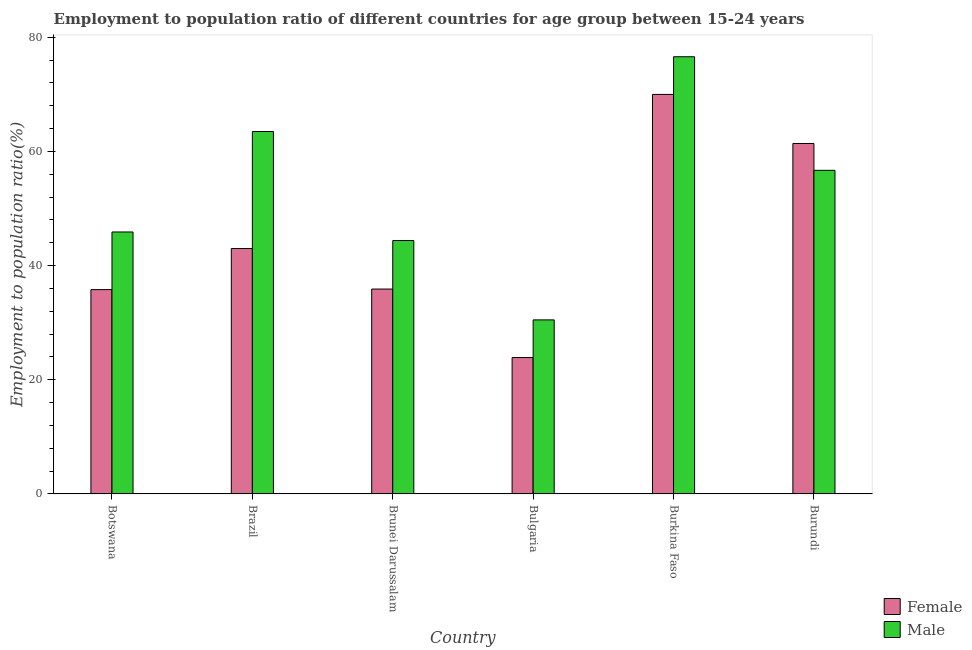How many different coloured bars are there?
Make the answer very short. 2. Are the number of bars per tick equal to the number of legend labels?
Your answer should be very brief. Yes. What is the label of the 6th group of bars from the left?
Ensure brevity in your answer.  Burundi. In how many cases, is the number of bars for a given country not equal to the number of legend labels?
Your answer should be very brief. 0. What is the employment to population ratio(female) in Brazil?
Keep it short and to the point. 43. Across all countries, what is the maximum employment to population ratio(female)?
Offer a terse response. 70. Across all countries, what is the minimum employment to population ratio(male)?
Provide a short and direct response. 30.5. In which country was the employment to population ratio(male) maximum?
Your answer should be very brief. Burkina Faso. What is the total employment to population ratio(female) in the graph?
Offer a terse response. 270. What is the difference between the employment to population ratio(female) in Botswana and that in Brunei Darussalam?
Give a very brief answer. -0.1. What is the difference between the employment to population ratio(male) in Brunei Darussalam and the employment to population ratio(female) in Botswana?
Your answer should be compact. 8.6. What is the average employment to population ratio(female) per country?
Your response must be concise. 45. What is the difference between the employment to population ratio(male) and employment to population ratio(female) in Botswana?
Keep it short and to the point. 10.1. What is the ratio of the employment to population ratio(female) in Brazil to that in Burkina Faso?
Offer a very short reply. 0.61. What is the difference between the highest and the second highest employment to population ratio(female)?
Keep it short and to the point. 8.6. What is the difference between the highest and the lowest employment to population ratio(female)?
Provide a succinct answer. 46.1. How many countries are there in the graph?
Give a very brief answer. 6. What is the difference between two consecutive major ticks on the Y-axis?
Provide a succinct answer. 20. What is the title of the graph?
Make the answer very short. Employment to population ratio of different countries for age group between 15-24 years. What is the label or title of the X-axis?
Your answer should be very brief. Country. What is the Employment to population ratio(%) of Female in Botswana?
Your answer should be very brief. 35.8. What is the Employment to population ratio(%) of Male in Botswana?
Ensure brevity in your answer.  45.9. What is the Employment to population ratio(%) in Male in Brazil?
Offer a terse response. 63.5. What is the Employment to population ratio(%) of Female in Brunei Darussalam?
Offer a very short reply. 35.9. What is the Employment to population ratio(%) in Male in Brunei Darussalam?
Make the answer very short. 44.4. What is the Employment to population ratio(%) in Female in Bulgaria?
Ensure brevity in your answer.  23.9. What is the Employment to population ratio(%) in Male in Bulgaria?
Offer a very short reply. 30.5. What is the Employment to population ratio(%) of Female in Burkina Faso?
Your answer should be compact. 70. What is the Employment to population ratio(%) of Male in Burkina Faso?
Keep it short and to the point. 76.6. What is the Employment to population ratio(%) in Female in Burundi?
Your response must be concise. 61.4. What is the Employment to population ratio(%) in Male in Burundi?
Make the answer very short. 56.7. Across all countries, what is the maximum Employment to population ratio(%) of Male?
Ensure brevity in your answer.  76.6. Across all countries, what is the minimum Employment to population ratio(%) in Female?
Provide a short and direct response. 23.9. Across all countries, what is the minimum Employment to population ratio(%) in Male?
Offer a very short reply. 30.5. What is the total Employment to population ratio(%) of Female in the graph?
Provide a short and direct response. 270. What is the total Employment to population ratio(%) in Male in the graph?
Give a very brief answer. 317.6. What is the difference between the Employment to population ratio(%) in Male in Botswana and that in Brazil?
Your response must be concise. -17.6. What is the difference between the Employment to population ratio(%) of Male in Botswana and that in Brunei Darussalam?
Your answer should be compact. 1.5. What is the difference between the Employment to population ratio(%) of Female in Botswana and that in Bulgaria?
Provide a short and direct response. 11.9. What is the difference between the Employment to population ratio(%) in Male in Botswana and that in Bulgaria?
Your response must be concise. 15.4. What is the difference between the Employment to population ratio(%) of Female in Botswana and that in Burkina Faso?
Provide a succinct answer. -34.2. What is the difference between the Employment to population ratio(%) in Male in Botswana and that in Burkina Faso?
Provide a short and direct response. -30.7. What is the difference between the Employment to population ratio(%) of Female in Botswana and that in Burundi?
Offer a terse response. -25.6. What is the difference between the Employment to population ratio(%) in Female in Brazil and that in Brunei Darussalam?
Give a very brief answer. 7.1. What is the difference between the Employment to population ratio(%) in Male in Brazil and that in Brunei Darussalam?
Offer a terse response. 19.1. What is the difference between the Employment to population ratio(%) of Male in Brazil and that in Bulgaria?
Offer a terse response. 33. What is the difference between the Employment to population ratio(%) in Female in Brazil and that in Burkina Faso?
Provide a succinct answer. -27. What is the difference between the Employment to population ratio(%) in Female in Brazil and that in Burundi?
Ensure brevity in your answer.  -18.4. What is the difference between the Employment to population ratio(%) in Male in Brunei Darussalam and that in Bulgaria?
Your response must be concise. 13.9. What is the difference between the Employment to population ratio(%) of Female in Brunei Darussalam and that in Burkina Faso?
Your answer should be compact. -34.1. What is the difference between the Employment to population ratio(%) of Male in Brunei Darussalam and that in Burkina Faso?
Your answer should be compact. -32.2. What is the difference between the Employment to population ratio(%) in Female in Brunei Darussalam and that in Burundi?
Offer a terse response. -25.5. What is the difference between the Employment to population ratio(%) of Female in Bulgaria and that in Burkina Faso?
Your response must be concise. -46.1. What is the difference between the Employment to population ratio(%) in Male in Bulgaria and that in Burkina Faso?
Give a very brief answer. -46.1. What is the difference between the Employment to population ratio(%) in Female in Bulgaria and that in Burundi?
Offer a very short reply. -37.5. What is the difference between the Employment to population ratio(%) of Male in Bulgaria and that in Burundi?
Ensure brevity in your answer.  -26.2. What is the difference between the Employment to population ratio(%) in Female in Botswana and the Employment to population ratio(%) in Male in Brazil?
Provide a short and direct response. -27.7. What is the difference between the Employment to population ratio(%) in Female in Botswana and the Employment to population ratio(%) in Male in Brunei Darussalam?
Your response must be concise. -8.6. What is the difference between the Employment to population ratio(%) in Female in Botswana and the Employment to population ratio(%) in Male in Bulgaria?
Keep it short and to the point. 5.3. What is the difference between the Employment to population ratio(%) of Female in Botswana and the Employment to population ratio(%) of Male in Burkina Faso?
Offer a very short reply. -40.8. What is the difference between the Employment to population ratio(%) of Female in Botswana and the Employment to population ratio(%) of Male in Burundi?
Offer a very short reply. -20.9. What is the difference between the Employment to population ratio(%) of Female in Brazil and the Employment to population ratio(%) of Male in Bulgaria?
Offer a very short reply. 12.5. What is the difference between the Employment to population ratio(%) in Female in Brazil and the Employment to population ratio(%) in Male in Burkina Faso?
Provide a succinct answer. -33.6. What is the difference between the Employment to population ratio(%) in Female in Brazil and the Employment to population ratio(%) in Male in Burundi?
Your answer should be very brief. -13.7. What is the difference between the Employment to population ratio(%) of Female in Brunei Darussalam and the Employment to population ratio(%) of Male in Bulgaria?
Offer a terse response. 5.4. What is the difference between the Employment to population ratio(%) of Female in Brunei Darussalam and the Employment to population ratio(%) of Male in Burkina Faso?
Provide a short and direct response. -40.7. What is the difference between the Employment to population ratio(%) in Female in Brunei Darussalam and the Employment to population ratio(%) in Male in Burundi?
Ensure brevity in your answer.  -20.8. What is the difference between the Employment to population ratio(%) of Female in Bulgaria and the Employment to population ratio(%) of Male in Burkina Faso?
Keep it short and to the point. -52.7. What is the difference between the Employment to population ratio(%) of Female in Bulgaria and the Employment to population ratio(%) of Male in Burundi?
Your answer should be very brief. -32.8. What is the difference between the Employment to population ratio(%) of Female in Burkina Faso and the Employment to population ratio(%) of Male in Burundi?
Your answer should be very brief. 13.3. What is the average Employment to population ratio(%) of Male per country?
Keep it short and to the point. 52.93. What is the difference between the Employment to population ratio(%) of Female and Employment to population ratio(%) of Male in Brazil?
Your answer should be very brief. -20.5. What is the difference between the Employment to population ratio(%) in Female and Employment to population ratio(%) in Male in Brunei Darussalam?
Make the answer very short. -8.5. What is the difference between the Employment to population ratio(%) in Female and Employment to population ratio(%) in Male in Bulgaria?
Ensure brevity in your answer.  -6.6. What is the difference between the Employment to population ratio(%) of Female and Employment to population ratio(%) of Male in Burkina Faso?
Your answer should be very brief. -6.6. What is the ratio of the Employment to population ratio(%) of Female in Botswana to that in Brazil?
Make the answer very short. 0.83. What is the ratio of the Employment to population ratio(%) of Male in Botswana to that in Brazil?
Your answer should be very brief. 0.72. What is the ratio of the Employment to population ratio(%) in Male in Botswana to that in Brunei Darussalam?
Make the answer very short. 1.03. What is the ratio of the Employment to population ratio(%) of Female in Botswana to that in Bulgaria?
Ensure brevity in your answer.  1.5. What is the ratio of the Employment to population ratio(%) in Male in Botswana to that in Bulgaria?
Make the answer very short. 1.5. What is the ratio of the Employment to population ratio(%) of Female in Botswana to that in Burkina Faso?
Offer a very short reply. 0.51. What is the ratio of the Employment to population ratio(%) in Male in Botswana to that in Burkina Faso?
Your answer should be compact. 0.6. What is the ratio of the Employment to population ratio(%) in Female in Botswana to that in Burundi?
Ensure brevity in your answer.  0.58. What is the ratio of the Employment to population ratio(%) of Male in Botswana to that in Burundi?
Keep it short and to the point. 0.81. What is the ratio of the Employment to population ratio(%) of Female in Brazil to that in Brunei Darussalam?
Your response must be concise. 1.2. What is the ratio of the Employment to population ratio(%) in Male in Brazil to that in Brunei Darussalam?
Ensure brevity in your answer.  1.43. What is the ratio of the Employment to population ratio(%) of Female in Brazil to that in Bulgaria?
Your answer should be very brief. 1.8. What is the ratio of the Employment to population ratio(%) in Male in Brazil to that in Bulgaria?
Your answer should be compact. 2.08. What is the ratio of the Employment to population ratio(%) of Female in Brazil to that in Burkina Faso?
Your answer should be compact. 0.61. What is the ratio of the Employment to population ratio(%) of Male in Brazil to that in Burkina Faso?
Ensure brevity in your answer.  0.83. What is the ratio of the Employment to population ratio(%) in Female in Brazil to that in Burundi?
Provide a short and direct response. 0.7. What is the ratio of the Employment to population ratio(%) of Male in Brazil to that in Burundi?
Offer a terse response. 1.12. What is the ratio of the Employment to population ratio(%) of Female in Brunei Darussalam to that in Bulgaria?
Provide a succinct answer. 1.5. What is the ratio of the Employment to population ratio(%) of Male in Brunei Darussalam to that in Bulgaria?
Offer a terse response. 1.46. What is the ratio of the Employment to population ratio(%) in Female in Brunei Darussalam to that in Burkina Faso?
Ensure brevity in your answer.  0.51. What is the ratio of the Employment to population ratio(%) of Male in Brunei Darussalam to that in Burkina Faso?
Offer a very short reply. 0.58. What is the ratio of the Employment to population ratio(%) in Female in Brunei Darussalam to that in Burundi?
Make the answer very short. 0.58. What is the ratio of the Employment to population ratio(%) of Male in Brunei Darussalam to that in Burundi?
Keep it short and to the point. 0.78. What is the ratio of the Employment to population ratio(%) of Female in Bulgaria to that in Burkina Faso?
Keep it short and to the point. 0.34. What is the ratio of the Employment to population ratio(%) of Male in Bulgaria to that in Burkina Faso?
Provide a short and direct response. 0.4. What is the ratio of the Employment to population ratio(%) in Female in Bulgaria to that in Burundi?
Offer a terse response. 0.39. What is the ratio of the Employment to population ratio(%) in Male in Bulgaria to that in Burundi?
Provide a short and direct response. 0.54. What is the ratio of the Employment to population ratio(%) of Female in Burkina Faso to that in Burundi?
Offer a terse response. 1.14. What is the ratio of the Employment to population ratio(%) in Male in Burkina Faso to that in Burundi?
Your answer should be very brief. 1.35. What is the difference between the highest and the second highest Employment to population ratio(%) of Female?
Ensure brevity in your answer.  8.6. What is the difference between the highest and the lowest Employment to population ratio(%) of Female?
Offer a very short reply. 46.1. What is the difference between the highest and the lowest Employment to population ratio(%) in Male?
Make the answer very short. 46.1. 